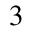<formula> <loc_0><loc_0><loc_500><loc_500>^ { 3 }</formula> 